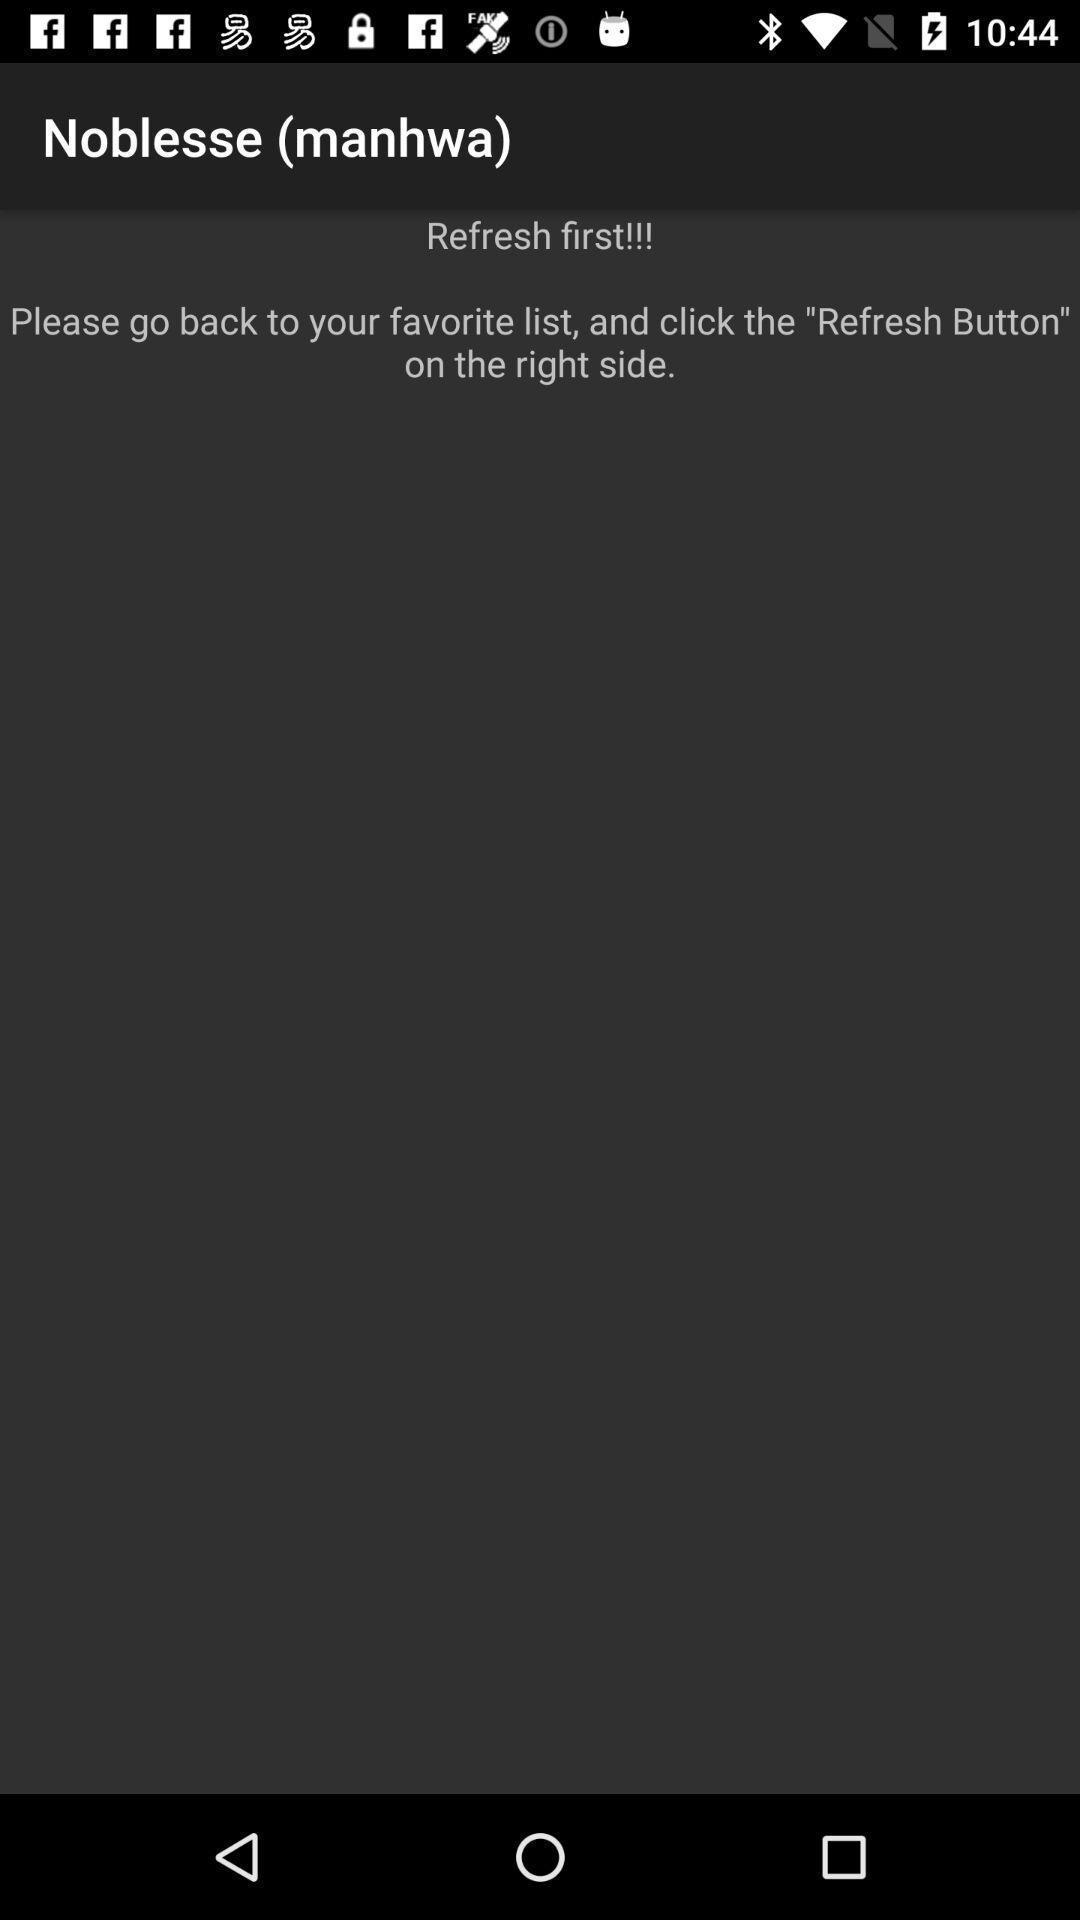Provide a detailed account of this screenshot. Screen shows about refreshing a page. 